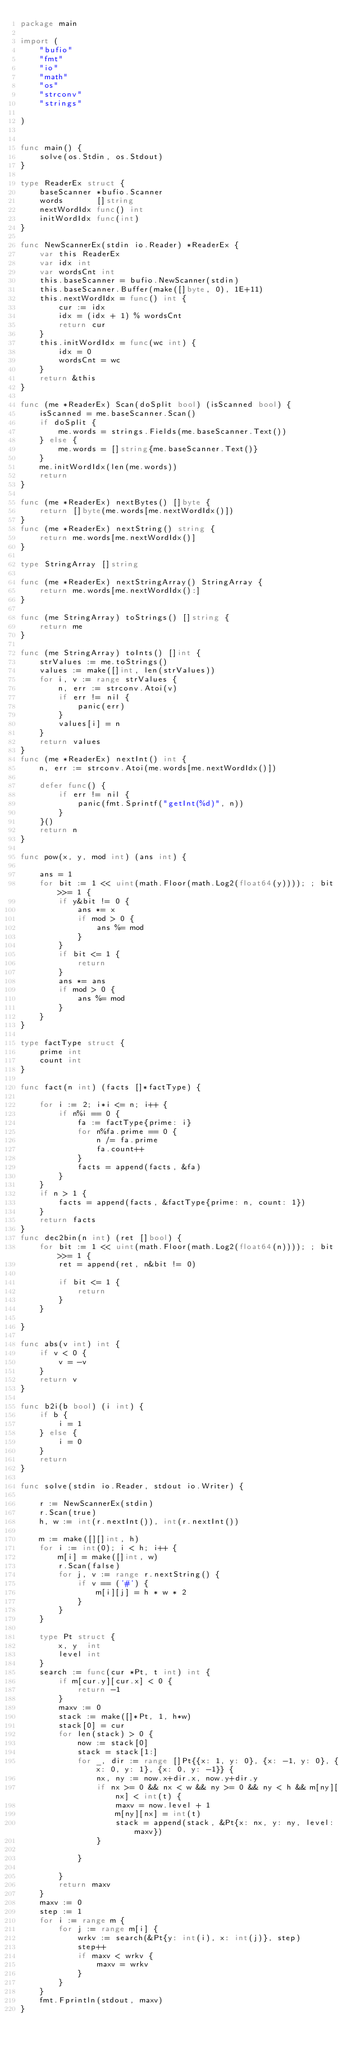Convert code to text. <code><loc_0><loc_0><loc_500><loc_500><_Go_>package main

import (
	"bufio"
	"fmt"
	"io"
	"math"
	"os"
	"strconv"
	"strings"

)


func main() {
	solve(os.Stdin, os.Stdout)
}

type ReaderEx struct {
	baseScanner *bufio.Scanner
	words       []string
	nextWordIdx func() int
	initWordIdx func(int)
}

func NewScannerEx(stdin io.Reader) *ReaderEx {
	var this ReaderEx
	var idx int
	var wordsCnt int
	this.baseScanner = bufio.NewScanner(stdin)
	this.baseScanner.Buffer(make([]byte, 0), 1E+11)
	this.nextWordIdx = func() int {
		cur := idx
		idx = (idx + 1) % wordsCnt
		return cur
	}
	this.initWordIdx = func(wc int) {
		idx = 0
		wordsCnt = wc
	}
	return &this
}

func (me *ReaderEx) Scan(doSplit bool) (isScanned bool) {
	isScanned = me.baseScanner.Scan()
	if doSplit {
		me.words = strings.Fields(me.baseScanner.Text())
	} else {
		me.words = []string{me.baseScanner.Text()}
	}
	me.initWordIdx(len(me.words))
	return
}

func (me *ReaderEx) nextBytes() []byte {
	return []byte(me.words[me.nextWordIdx()])
}
func (me *ReaderEx) nextString() string {
	return me.words[me.nextWordIdx()]
}

type StringArray []string

func (me *ReaderEx) nextStringArray() StringArray {
	return me.words[me.nextWordIdx():]
}

func (me StringArray) toStrings() []string {
	return me
}

func (me StringArray) toInts() []int {
	strValues := me.toStrings()
	values := make([]int, len(strValues))
	for i, v := range strValues {
		n, err := strconv.Atoi(v)
		if err != nil {
			panic(err)
		}
		values[i] = n
	}
	return values
}
func (me *ReaderEx) nextInt() int {
	n, err := strconv.Atoi(me.words[me.nextWordIdx()])

	defer func() {
		if err != nil {
			panic(fmt.Sprintf("getInt(%d)", n))
		}
	}()
	return n
}

func pow(x, y, mod int) (ans int) {

	ans = 1
	for bit := 1 << uint(math.Floor(math.Log2(float64(y)))); ; bit >>= 1 {
		if y&bit != 0 {
			ans *= x
			if mod > 0 {
				ans %= mod
			}
		}
		if bit <= 1 {
			return
		}
		ans *= ans
		if mod > 0 {
			ans %= mod
		}
	}
}

type factType struct {
	prime int
	count int
}

func fact(n int) (facts []*factType) {

	for i := 2; i*i <= n; i++ {
		if n%i == 0 {
			fa := factType{prime: i}
			for n%fa.prime == 0 {
				n /= fa.prime
				fa.count++
			}
			facts = append(facts, &fa)
		}
	}
	if n > 1 {
		facts = append(facts, &factType{prime: n, count: 1})
	}
	return facts
}
func dec2bin(n int) (ret []bool) {
	for bit := 1 << uint(math.Floor(math.Log2(float64(n)))); ; bit >>= 1 {
		ret = append(ret, n&bit != 0)

		if bit <= 1 {
			return
		}
	}

}

func abs(v int) int {
	if v < 0 {
		v = -v
	}
	return v
}

func b2i(b bool) (i int) {
	if b {
		i = 1
	} else {
		i = 0
	}
	return
}

func solve(stdin io.Reader, stdout io.Writer) {

	r := NewScannerEx(stdin)
	r.Scan(true)
	h, w := int(r.nextInt()), int(r.nextInt())

	m := make([][]int, h)
	for i := int(0); i < h; i++ {
		m[i] = make([]int, w)
		r.Scan(false)
		for j, v := range r.nextString() {
			if v == ('#') {
				m[i][j] = h * w * 2
			}
		}
	}

	type Pt struct {
		x, y  int
		level int
	}
	search := func(cur *Pt, t int) int {
		if m[cur.y][cur.x] < 0 {
			return -1
		}
		maxv := 0
		stack := make([]*Pt, 1, h*w)
		stack[0] = cur
		for len(stack) > 0 {
			now := stack[0]
			stack = stack[1:]
			for _, dir := range []Pt{{x: 1, y: 0}, {x: -1, y: 0}, {x: 0, y: 1}, {x: 0, y: -1}} {
				nx, ny := now.x+dir.x, now.y+dir.y
				if nx >= 0 && nx < w && ny >= 0 && ny < h && m[ny][nx] < int(t) {
					maxv = now.level + 1
					m[ny][nx] = int(t)
					stack = append(stack, &Pt{x: nx, y: ny, level: maxv})
				}

			}

		}
		return maxv
	}
	maxv := 0
	step := 1
	for i := range m {
		for j := range m[i] {
			wrkv := search(&Pt{y: int(i), x: int(j)}, step)
			step++
			if maxv < wrkv {
				maxv = wrkv
			}
		}
	}
	fmt.Fprintln(stdout, maxv)
}
</code> 